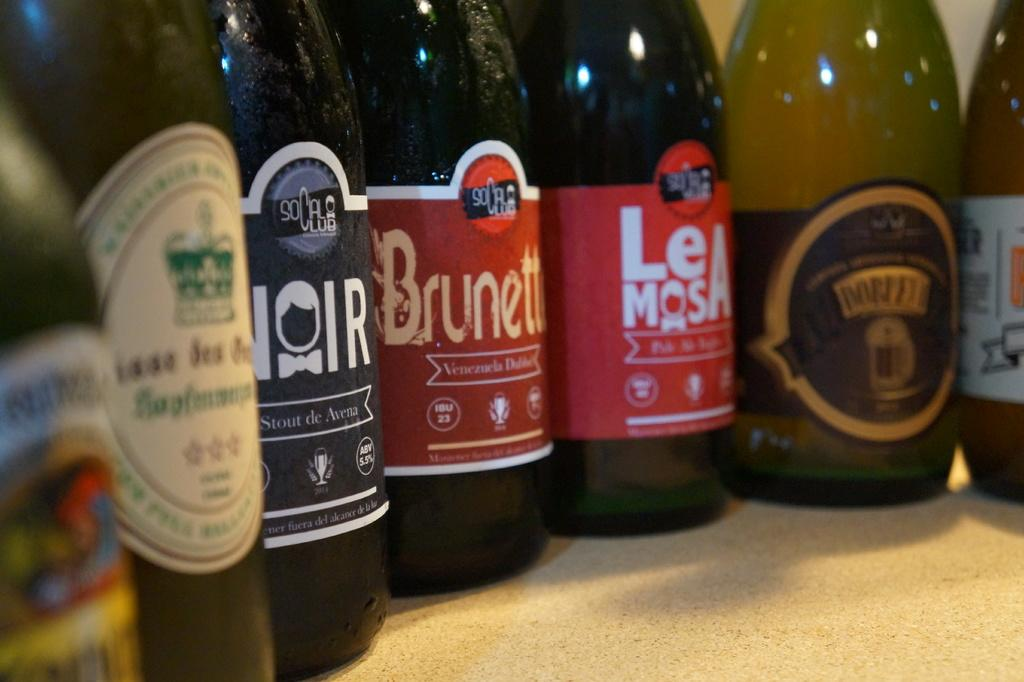<image>
Describe the image concisely. Bottles of beer with one that says "NOIR". 